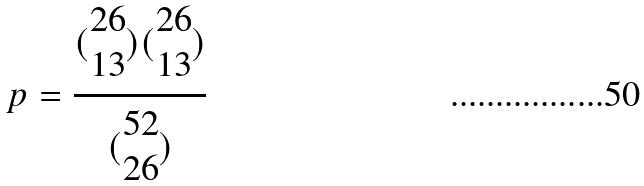Convert formula to latex. <formula><loc_0><loc_0><loc_500><loc_500>p = \frac { ( \begin{matrix} 2 6 \\ 1 3 \end{matrix} ) ( \begin{matrix} 2 6 \\ 1 3 \end{matrix} ) } { ( \begin{matrix} 5 2 \\ 2 6 \end{matrix} ) }</formula> 